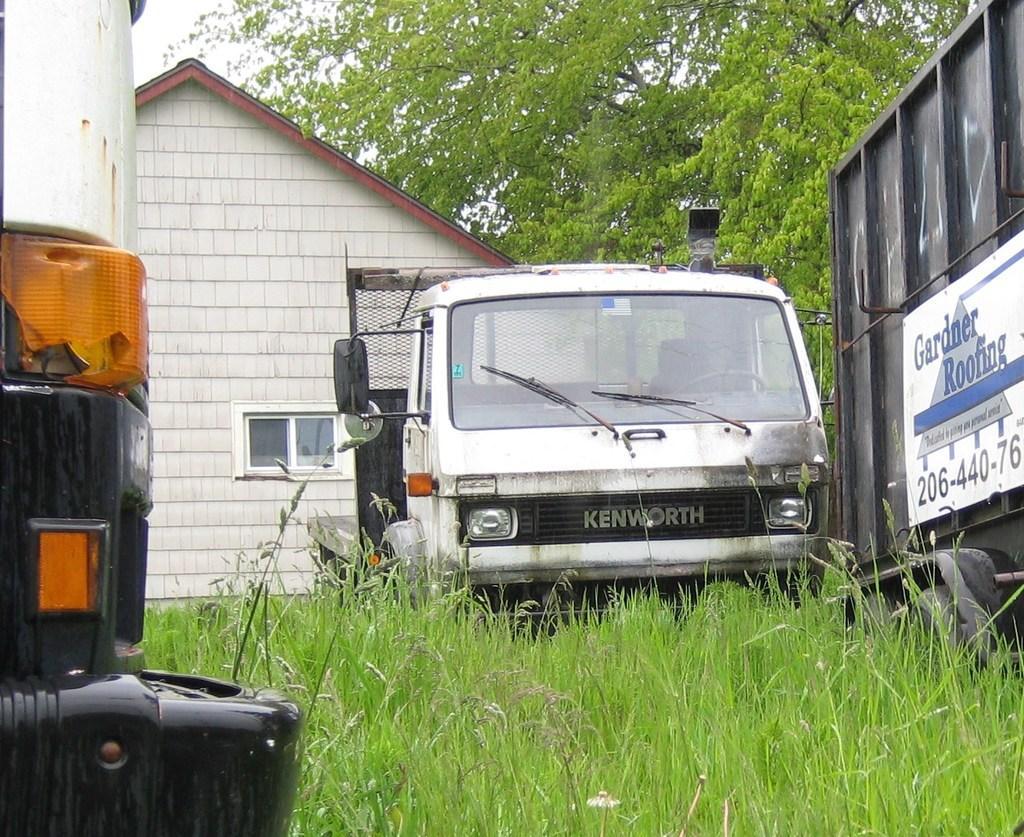Describe this image in one or two sentences. In this image I can see grass and few vehicles in the front. In the background I can see a building, a window, a tree and the sky. On the right side of the image I can see something is written on the white colour board. 